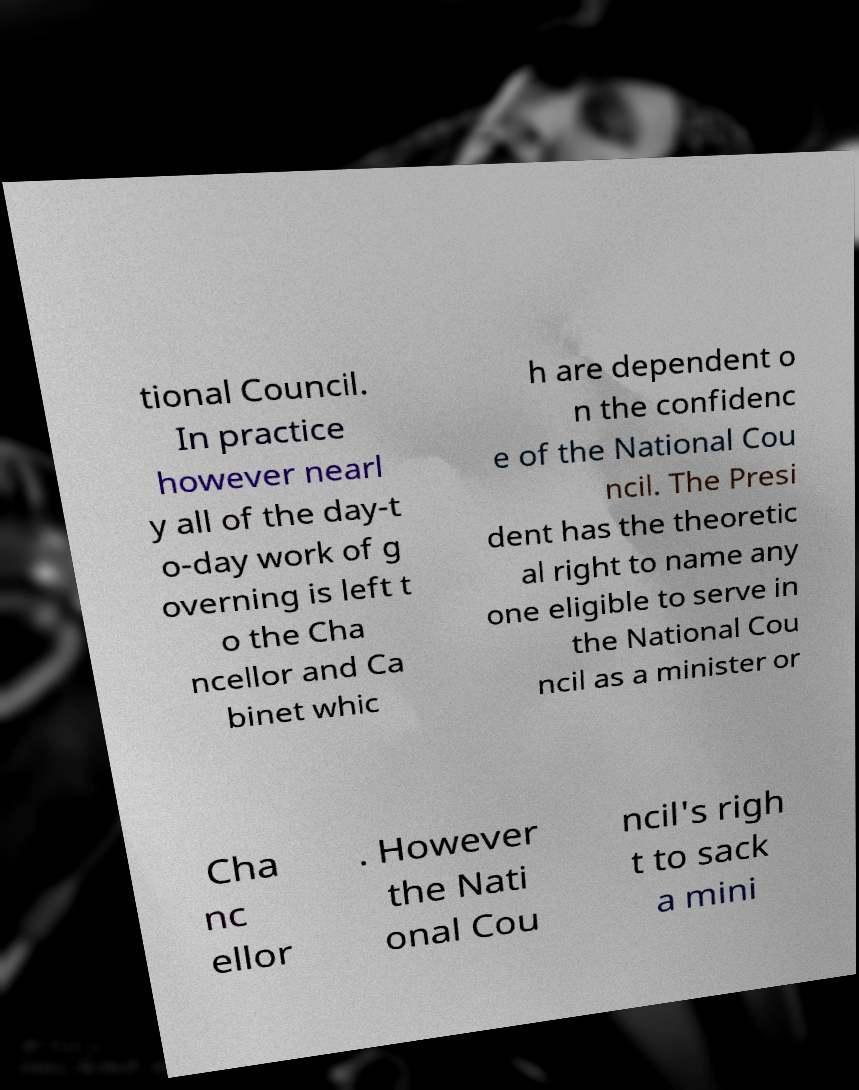Please read and relay the text visible in this image. What does it say? tional Council. In practice however nearl y all of the day-t o-day work of g overning is left t o the Cha ncellor and Ca binet whic h are dependent o n the confidenc e of the National Cou ncil. The Presi dent has the theoretic al right to name any one eligible to serve in the National Cou ncil as a minister or Cha nc ellor . However the Nati onal Cou ncil's righ t to sack a mini 